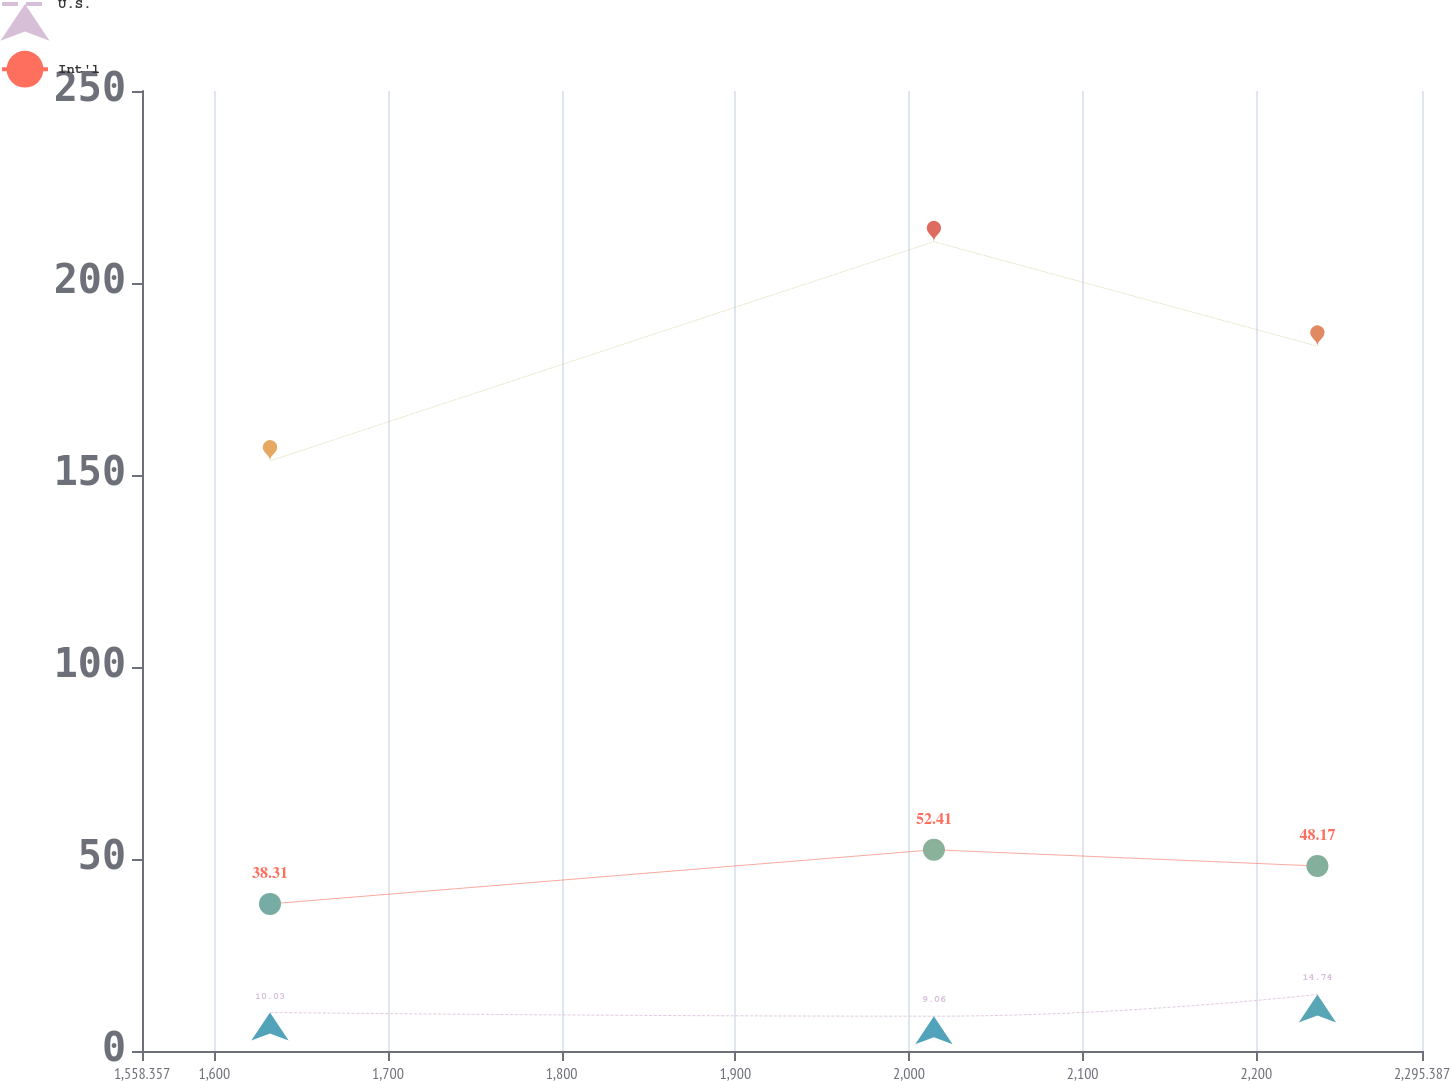Convert chart to OTSL. <chart><loc_0><loc_0><loc_500><loc_500><line_chart><ecel><fcel>Unnamed: 1<fcel>U.S.<fcel>Int'l<nl><fcel>1632.06<fcel>153.67<fcel>10.03<fcel>38.31<nl><fcel>2014.34<fcel>210.76<fcel>9.06<fcel>52.41<nl><fcel>2235.17<fcel>183.55<fcel>14.74<fcel>48.17<nl><fcel>2302.13<fcel>196.65<fcel>13.77<fcel>44.37<nl><fcel>2369.09<fcel>239.84<fcel>18.77<fcel>61.02<nl></chart> 